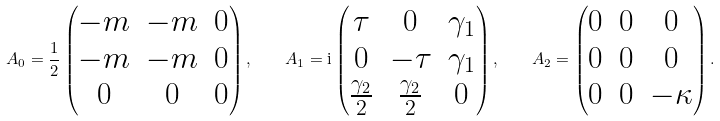<formula> <loc_0><loc_0><loc_500><loc_500>A _ { 0 } = \frac { 1 } { 2 } \begin{pmatrix} - m & - m & 0 \\ - m & - m & 0 \\ 0 & 0 & 0 \end{pmatrix} , \quad A _ { 1 } = \mathrm i \begin{pmatrix} \tau & 0 & \gamma _ { 1 } \\ 0 & - \tau & \gamma _ { 1 } \\ \frac { \gamma _ { 2 } } 2 & \frac { \gamma _ { 2 } } 2 & 0 \end{pmatrix} , \quad A _ { 2 } = \begin{pmatrix} 0 & 0 & 0 \\ 0 & 0 & 0 \\ 0 & 0 & - \kappa \end{pmatrix} .</formula> 